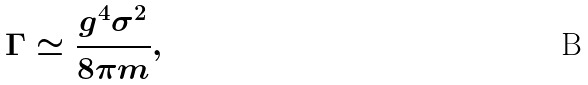Convert formula to latex. <formula><loc_0><loc_0><loc_500><loc_500>\Gamma \simeq \frac { g ^ { 4 } \sigma ^ { 2 } } { 8 \pi m } ,</formula> 